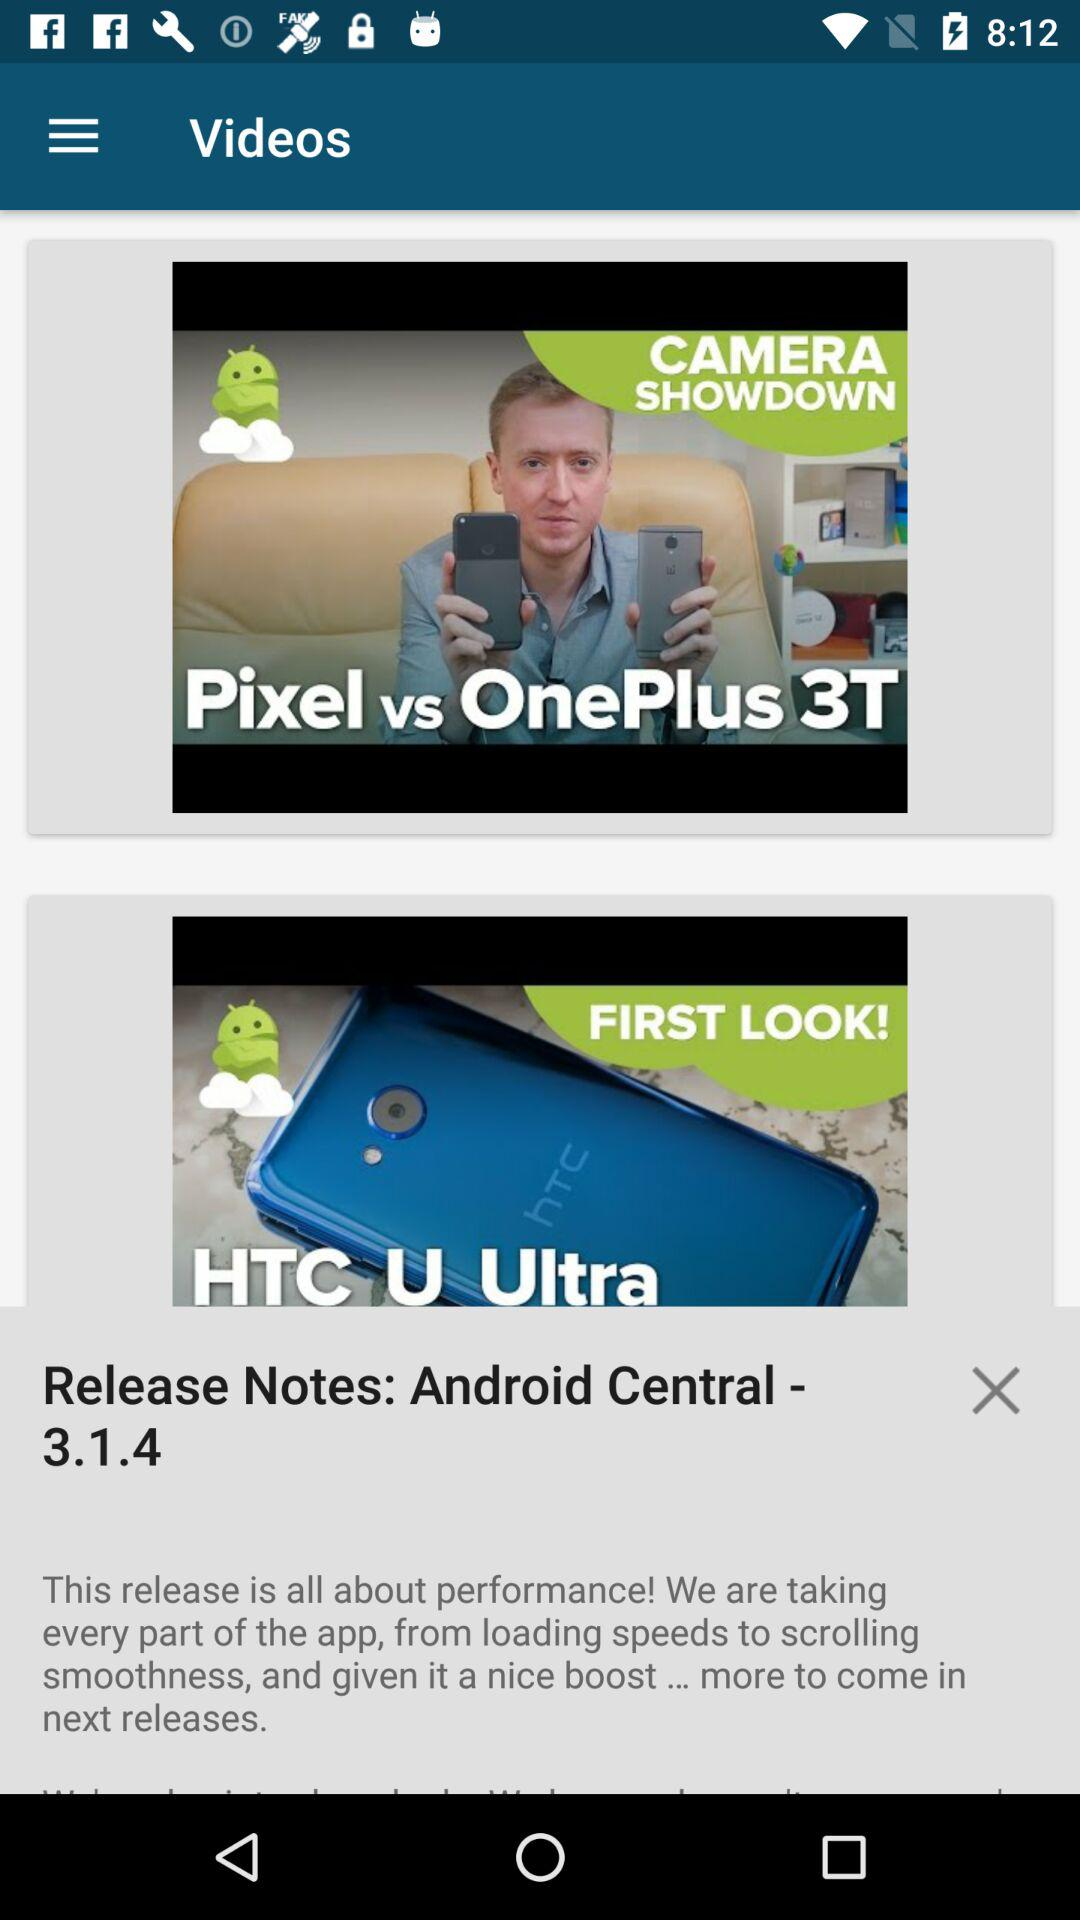What is the name of the application? The name of the application is "Android Central". 